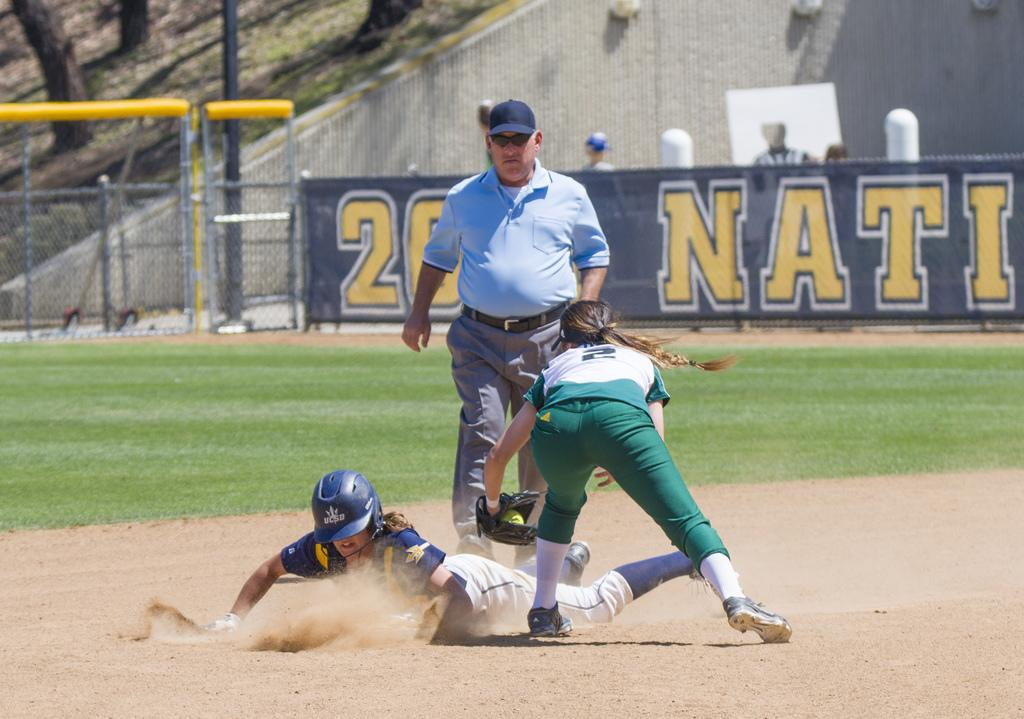<image>
Write a terse but informative summary of the picture. a player slides into the base wearing a navy helmet by VCSO 